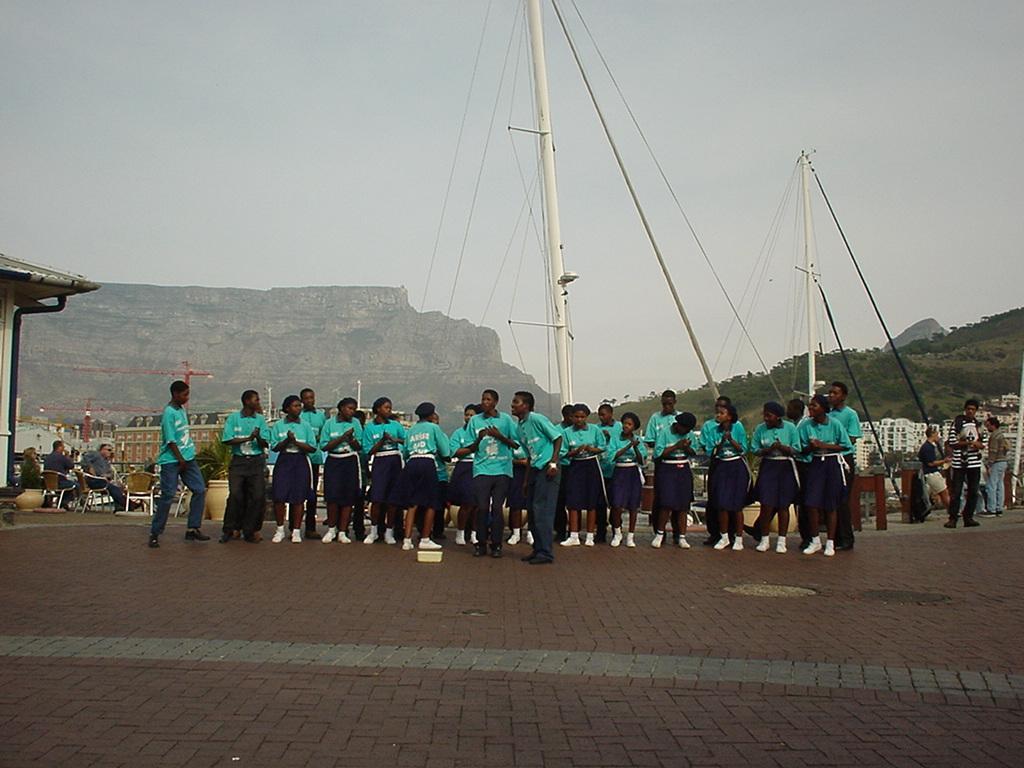Please provide a concise description of this image. There are people and we can see plants with pots, roof top, poles and ropes. In the background we can see buildings, trees and sky. 